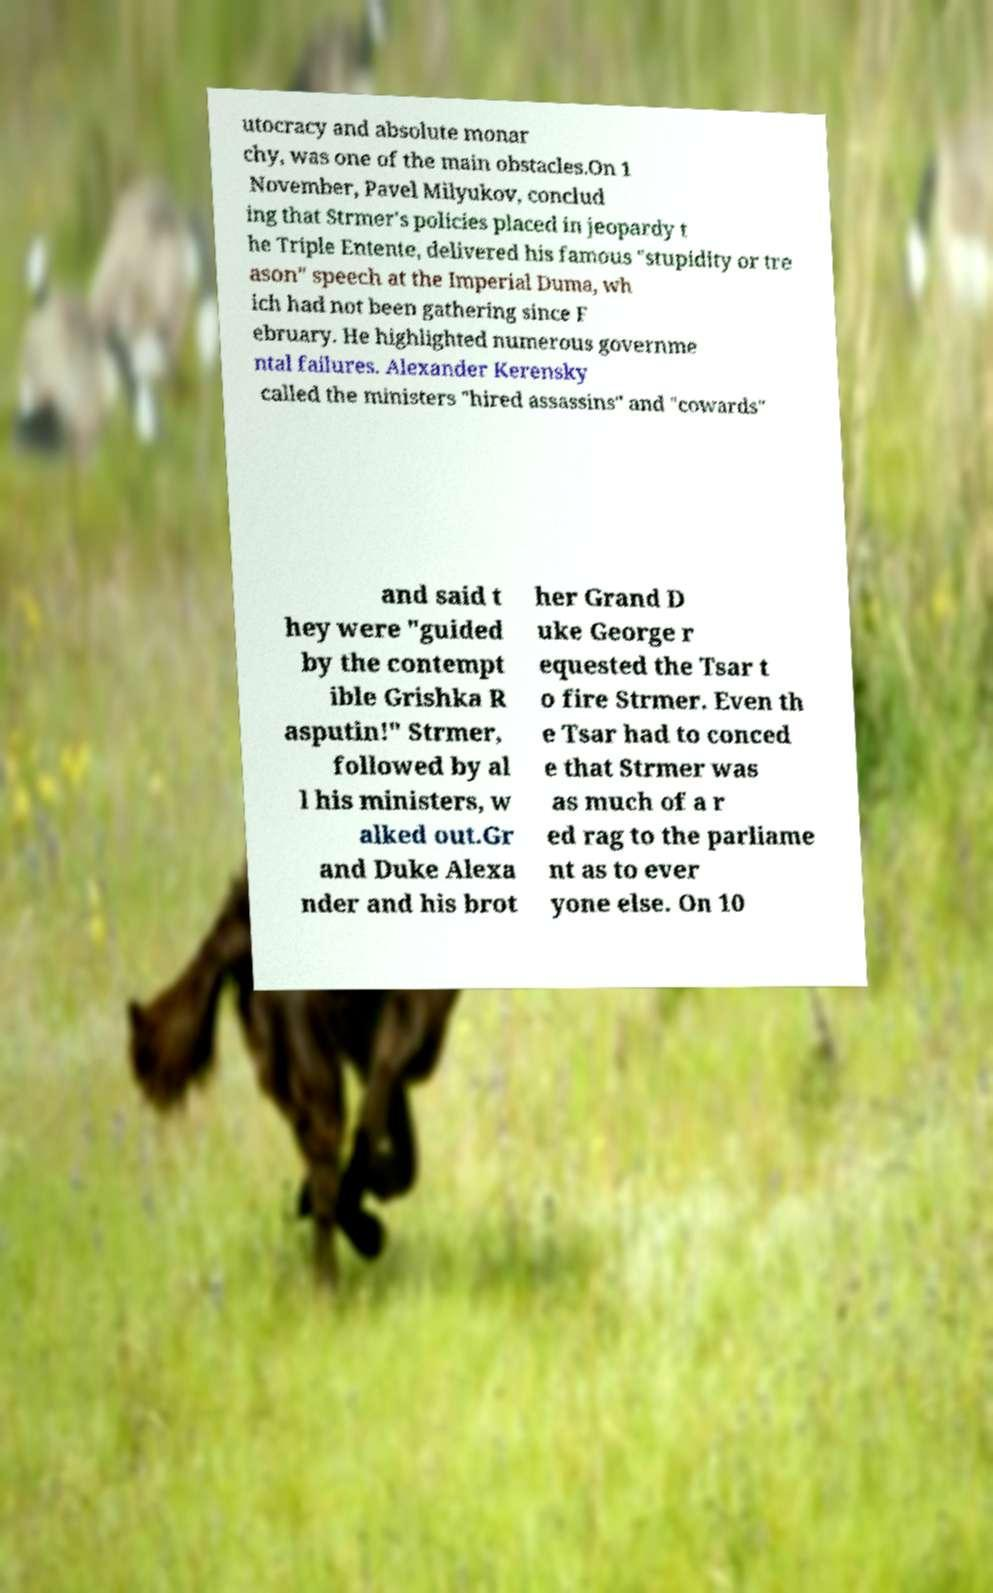Can you read and provide the text displayed in the image?This photo seems to have some interesting text. Can you extract and type it out for me? utocracy and absolute monar chy, was one of the main obstacles.On 1 November, Pavel Milyukov, conclud ing that Strmer's policies placed in jeopardy t he Triple Entente, delivered his famous "stupidity or tre ason" speech at the Imperial Duma, wh ich had not been gathering since F ebruary. He highlighted numerous governme ntal failures. Alexander Kerensky called the ministers "hired assassins" and "cowards" and said t hey were "guided by the contempt ible Grishka R asputin!" Strmer, followed by al l his ministers, w alked out.Gr and Duke Alexa nder and his brot her Grand D uke George r equested the Tsar t o fire Strmer. Even th e Tsar had to conced e that Strmer was as much of a r ed rag to the parliame nt as to ever yone else. On 10 